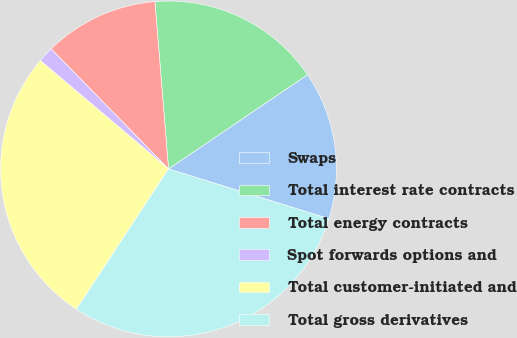<chart> <loc_0><loc_0><loc_500><loc_500><pie_chart><fcel>Swaps<fcel>Total interest rate contracts<fcel>Total energy contracts<fcel>Spot forwards options and<fcel>Total customer-initiated and<fcel>Total gross derivatives<nl><fcel>14.27%<fcel>16.81%<fcel>11.03%<fcel>1.51%<fcel>26.92%<fcel>29.46%<nl></chart> 